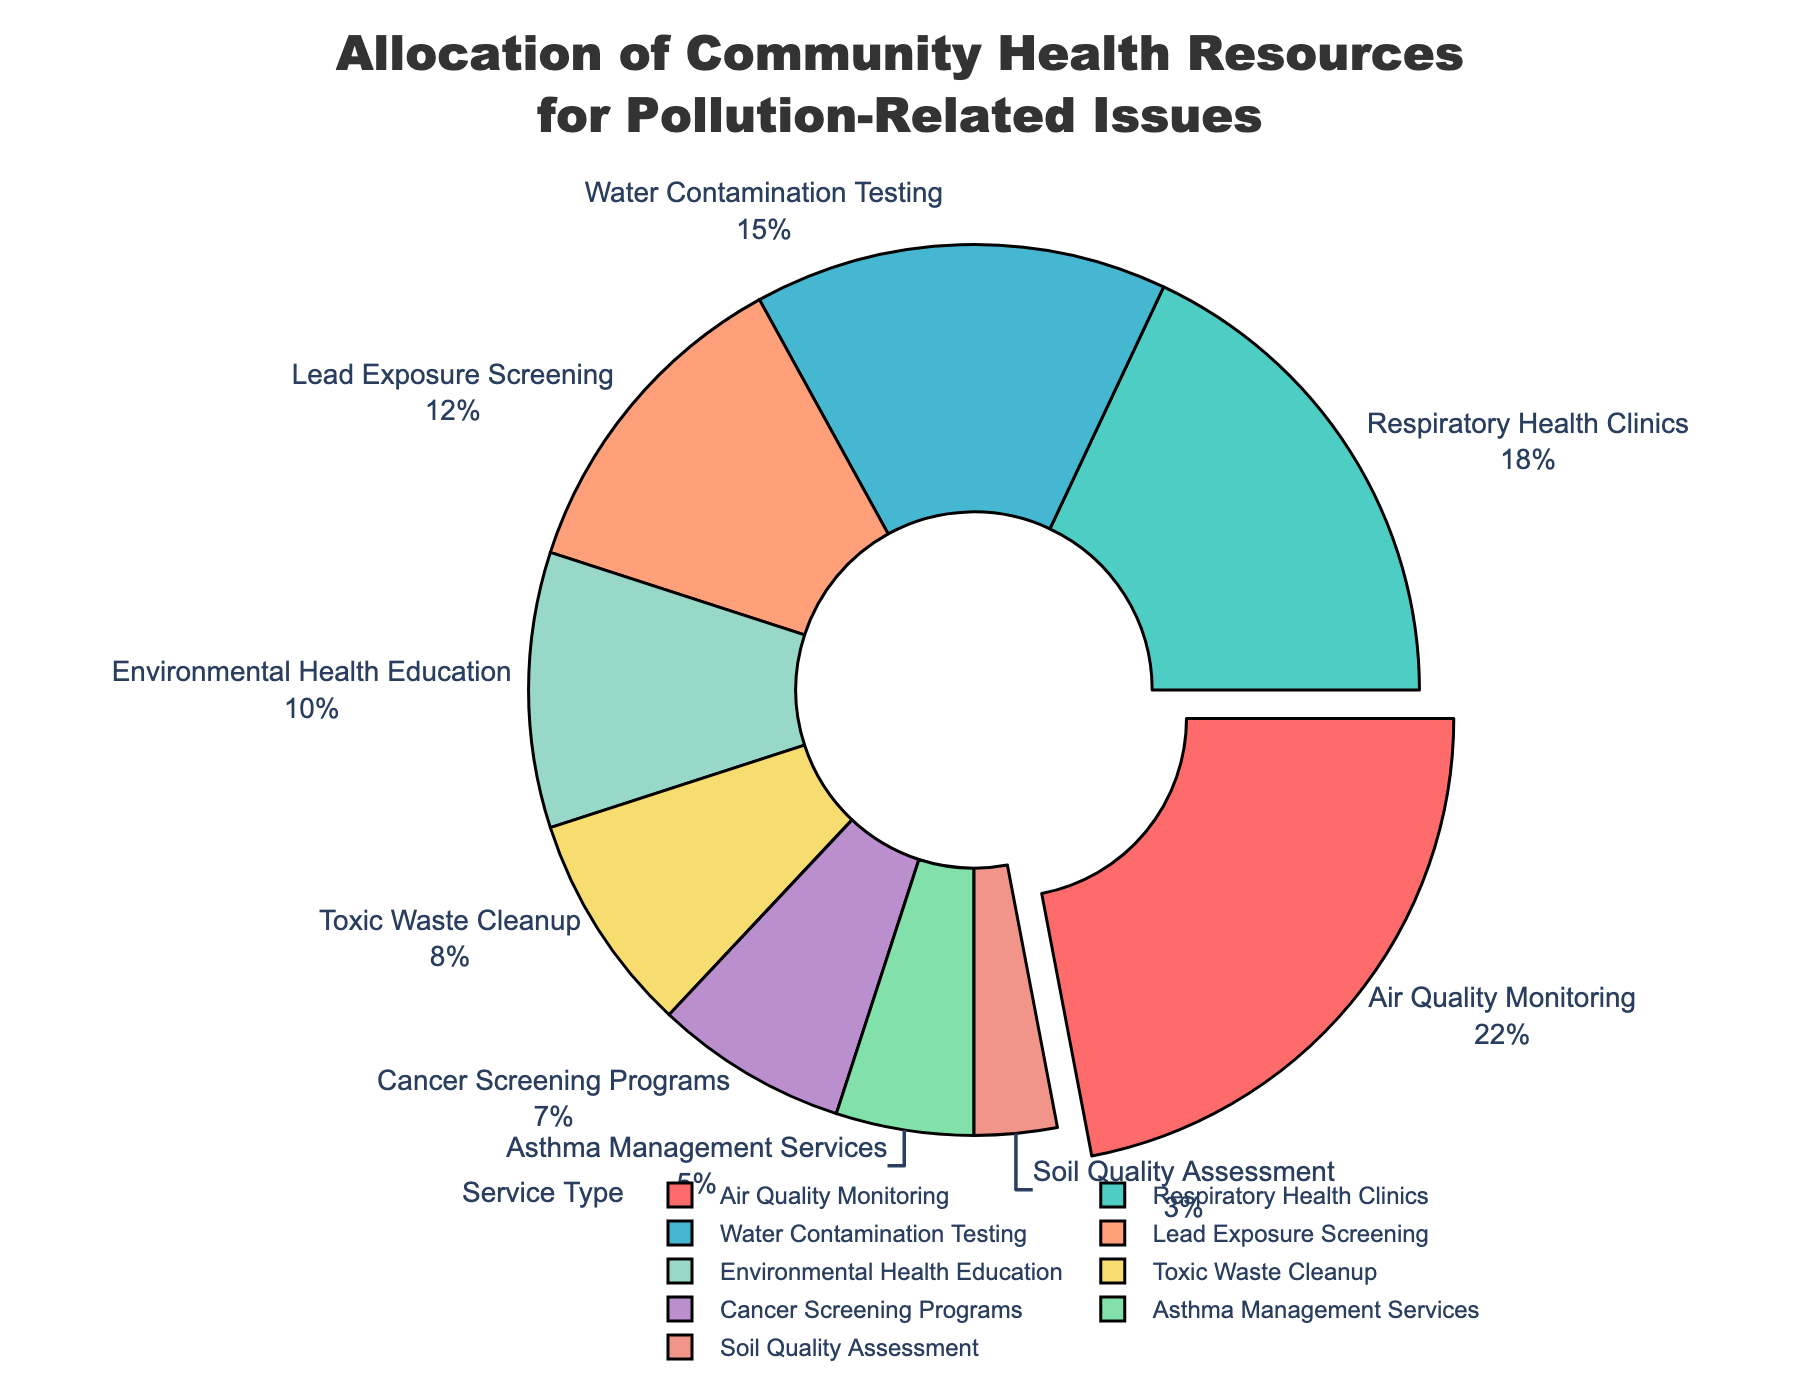What percentage of the budget is allocated to Air Quality Monitoring? Identify the section in the pie chart labeled "Air Quality Monitoring" and read the percentage value shown.
Answer: 22% Which service type receives the smallest portion of the budget? Locate the smallest segment in the pie chart and read the label, which identifies the service type with the smallest budget allocation.
Answer: Soil Quality Assessment How much more budget percentage is allocated to Respiratory Health Clinics compared to Asthma Management Services? Find and note the budget percentages for both "Respiratory Health Clinics" and "Asthma Management Services". Calculate the difference: 18 - 5.
Answer: 13% What is the combined budget percentage for Lead Exposure Screening and Environmental Health Education? Find and add the budget percentages for "Lead Exposure Screening" and "Environmental Health Education": 12 + 10.
Answer: 22% Compare the budget allocation for Toxic Waste Cleanup to Cancer Screening Programs. Which one is higher, and by how much? Identify the budget percentages for "Toxic Waste Cleanup" (8%) and "Cancer Screening Programs" (7%), then determine which is higher and subtract the smaller percentage: 8 - 7.
Answer: Toxic Waste Cleanup, by 1% What proportion of the budget is dedicated to services directly related to respiratory health (Respiratory Health Clinics and Asthma Management Services)? Find the budget percentages for "Respiratory Health Clinics" and "Asthma Management Services" and add them: 18 + 5.
Answer: 23% Identify the service type represented by the green color slice in the pie chart. Look at the pie chart and find the segment colored green, then read the label corresponding to that color.
Answer: Respiratory Health Clinics How does the budget allocation for Water Contamination Testing compare to that for Lead Exposure Screening? Note the budget percentages for "Water Contamination Testing" (15%) and "Lead Exposure Screening" (12%). Determine which is higher by subtracting the smaller percentage from the larger: 15 - 12.
Answer: Water Contamination Testing, by 3% Which service type has the largest budget allocation and how is it visually distinguished from the others? Identify the segment with the largest percentage, in this case, "Air Quality Monitoring" (22%), which is likely pulled out slightly from the pie chart.
Answer: Air Quality Monitoring What is the total budget percentage allocated to both Toxic Waste Cleanup and Cancer Screening Programs? Add the budget percentages for "Toxic Waste Cleanup" (8%) and "Cancer Screening Programs" (7%): 8 + 7.
Answer: 15% 